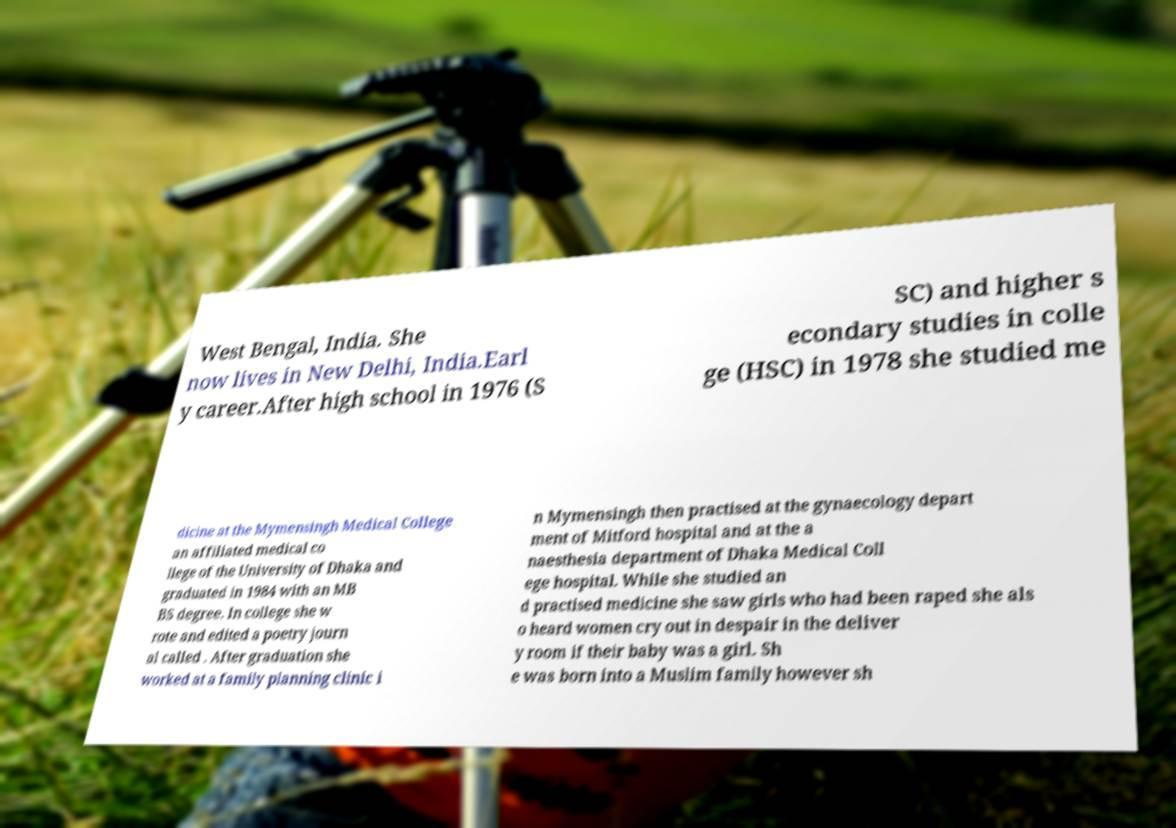Please identify and transcribe the text found in this image. West Bengal, India. She now lives in New Delhi, India.Earl y career.After high school in 1976 (S SC) and higher s econdary studies in colle ge (HSC) in 1978 she studied me dicine at the Mymensingh Medical College an affiliated medical co llege of the University of Dhaka and graduated in 1984 with an MB BS degree. In college she w rote and edited a poetry journ al called . After graduation she worked at a family planning clinic i n Mymensingh then practised at the gynaecology depart ment of Mitford hospital and at the a naesthesia department of Dhaka Medical Coll ege hospital. While she studied an d practised medicine she saw girls who had been raped she als o heard women cry out in despair in the deliver y room if their baby was a girl. Sh e was born into a Muslim family however sh 